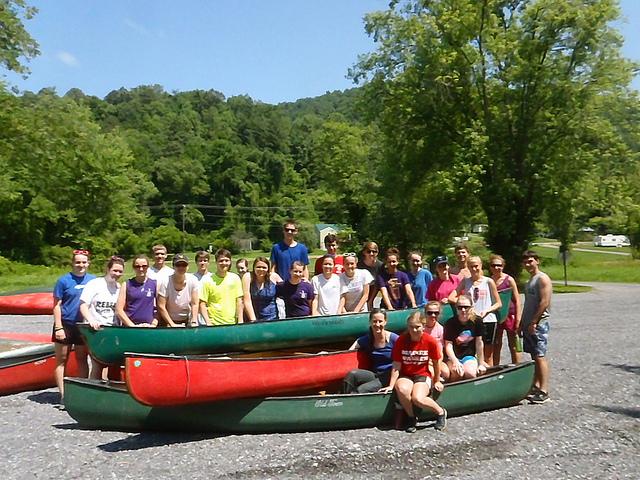How many people are in the picture?
Short answer required. 26. What kind of boats are these?
Write a very short answer. Canoes. How many boats are green?
Short answer required. 2. 